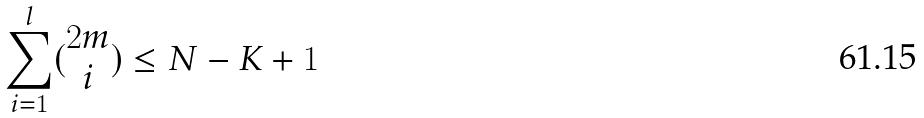Convert formula to latex. <formula><loc_0><loc_0><loc_500><loc_500>\sum _ { i = 1 } ^ { l } ( \begin{matrix} 2 m \\ i \end{matrix} ) \leq N - K + 1</formula> 